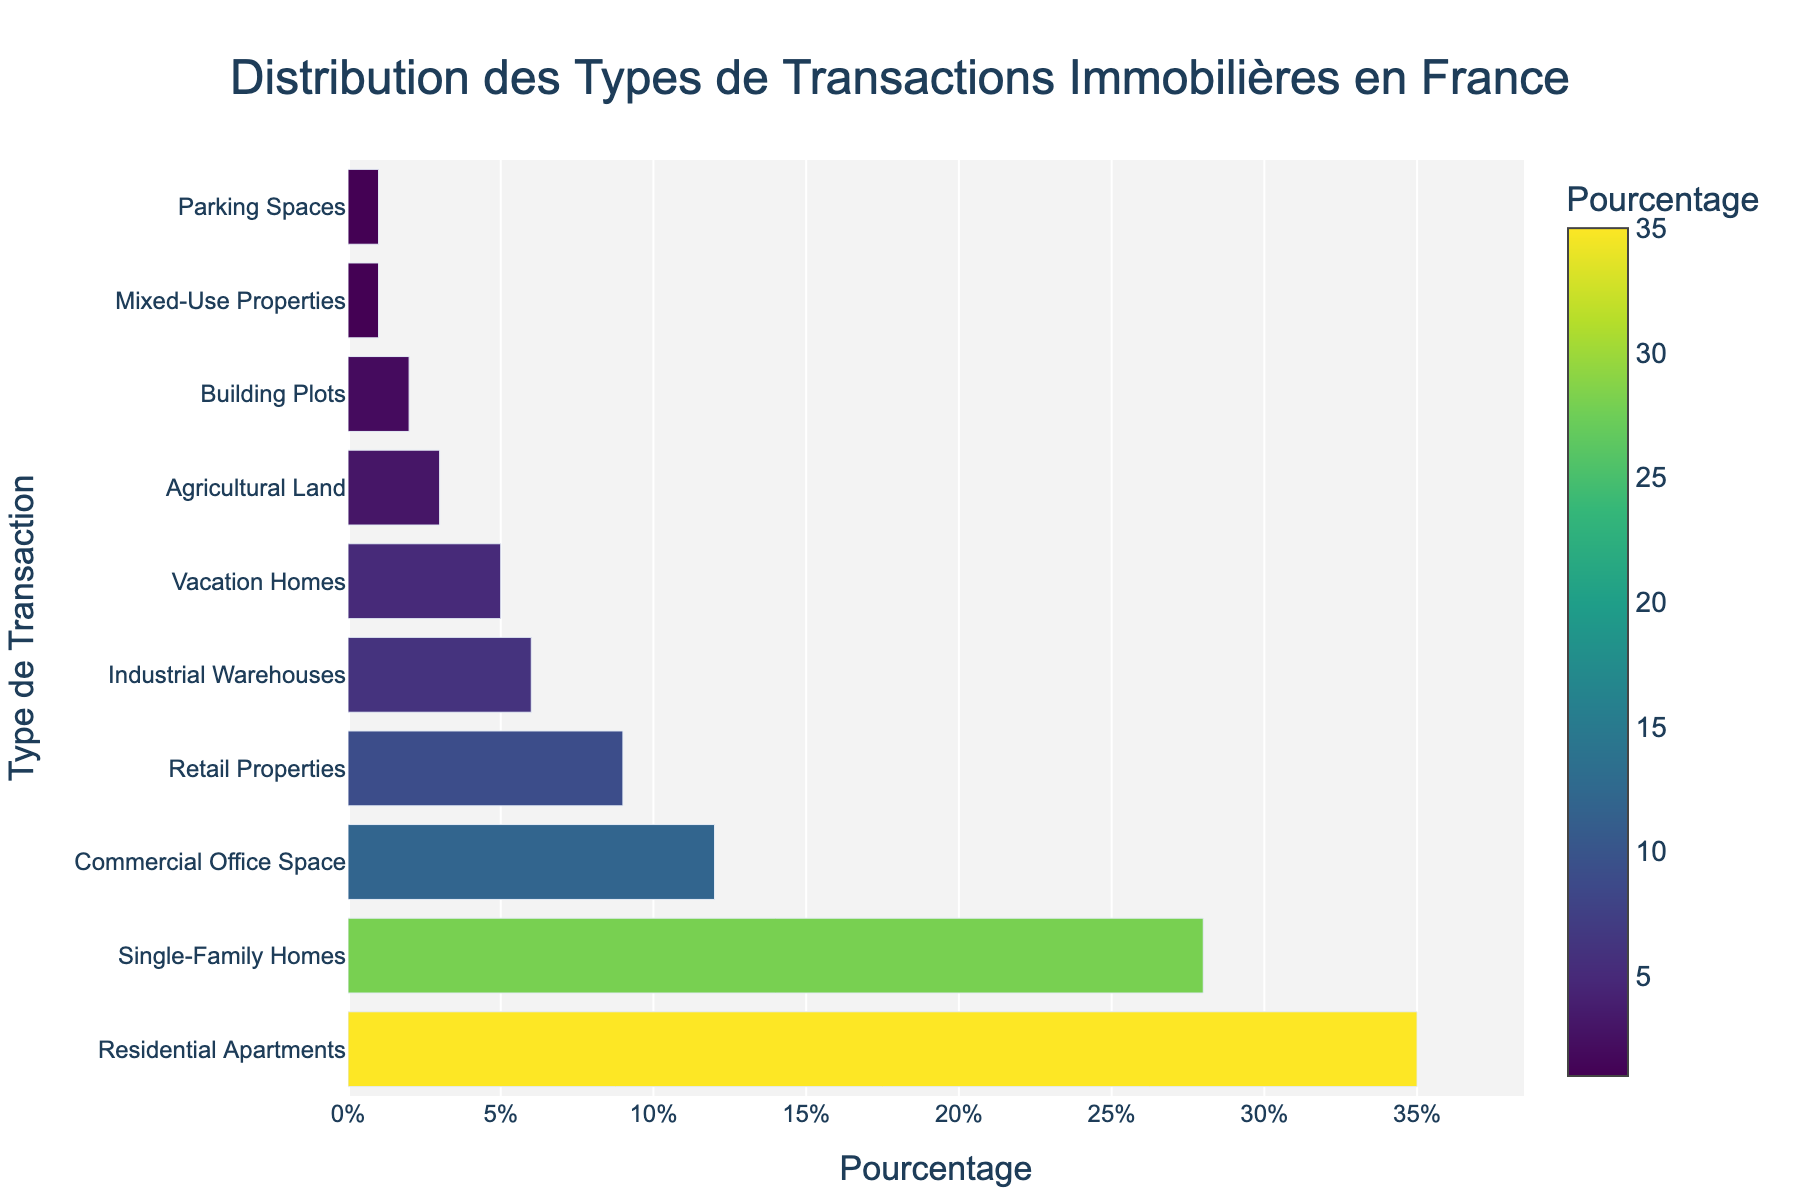Which transaction type has the highest percentage? The chart shows that the bar corresponding to "Residential Apartments" is the longest and has the highest percentage value among all transaction types.
Answer: Residential Apartments What is the combined percentage of 'Single-Family Homes' and 'Commercial Office Space'? 'Single-Family Homes' has a percentage of 28% and 'Commercial Office Space' has a percentage of 12%. Adding these together gives 28% + 12% = 40%.
Answer: 40% Is the percentage of 'Industrial Warehouses' greater than 'Retail Properties'? The chart shows that 'Industrial Warehouses' has a percentage of 6% while 'Retail Properties' has a percentage of 9%. Since 6% is less than 9%, 'Industrial Warehouses' is not greater than 'Retail Properties'.
Answer: No How does the percentage of 'Vacation Homes' compare to 'Agricultural Land'? 'Vacation Homes' has a percentage of 5%, and 'Agricultural Land' has a percentage of 3%. Since 5% is greater than 3%, 'Vacation Homes' has a higher percentage.
Answer: Greater What percentage of transactions are 'Mixed-Use Properties' and 'Parking Spaces' combined? 'Mixed-Use Properties' has a percentage of 1%, and 'Parking Spaces' also has a percentage of 1%. Adding these together gives 1% + 1% = 2%.
Answer: 2% What is the difference in percentage between the highest and the lowest transaction types? The highest percentage is for 'Residential Apartments' at 35%, and the lowest percentages are for 'Mixed-Use Properties' and 'Parking Spaces' both at 1%. The difference is 35% - 1% = 34%.
Answer: 34% Which transaction type has the third highest percentage? By observing the lengths of the bars in descending order, the third longest bar is 'Commercial Office Space' with a percentage of 12%.
Answer: Commercial Office Space What color represents the 'Building Plots' percentage? The 'Building Plots' bar is colored according to the Viridis color scale. Visually, it is positioned towards the lower value end of the colors, likely around a greenish shade.
Answer: Greenish How many transaction types have a percentage greater than 10%? By examining the lengths of the bars labeled with more than 10%, there are three transaction types: 'Residential Apartments', 'Single-Family Homes', and 'Commercial Office Space'.
Answer: 3 What is the average percentage of 'Agricultural Land', 'Building Plots', and 'Mixed-Use Properties'? The percentages are 3% for 'Agricultural Land', 2% for 'Building Plots', and 1% for 'Mixed-Use Properties'. The average is (3% + 2% + 1%) / 3 = 2%.
Answer: 2% 